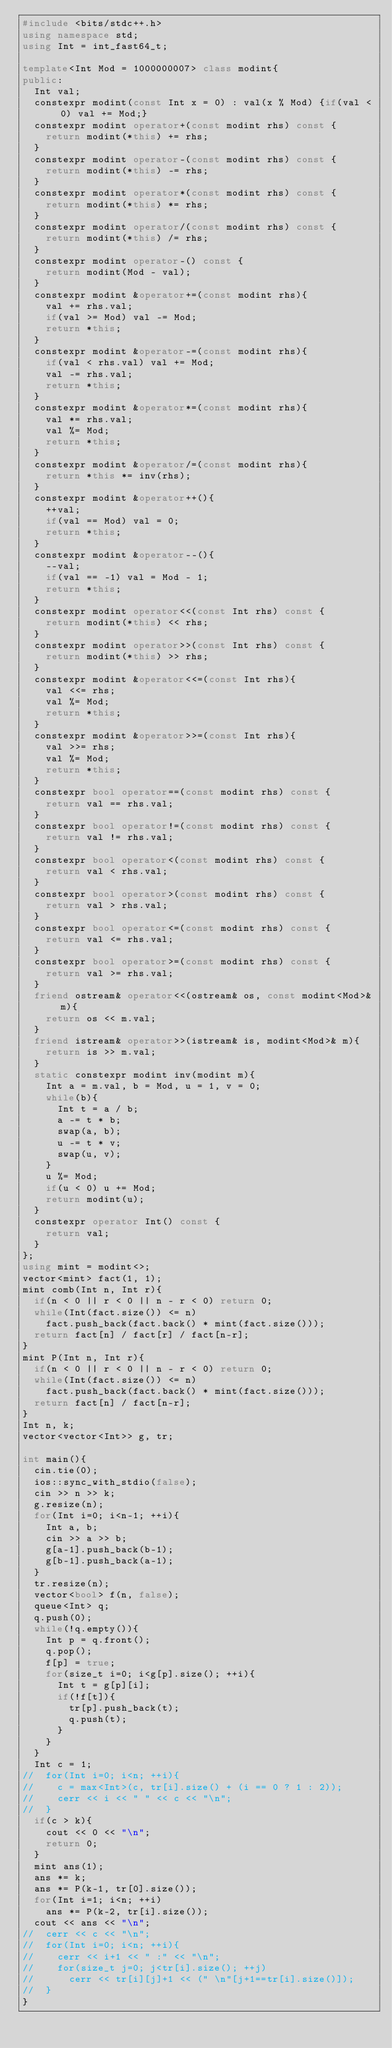Convert code to text. <code><loc_0><loc_0><loc_500><loc_500><_C++_>#include <bits/stdc++.h>
using namespace std;
using Int = int_fast64_t;

template<Int Mod = 1000000007> class modint{
public:
	Int val;
	constexpr modint(const Int x = 0) : val(x % Mod) {if(val < 0) val += Mod;}
	constexpr modint operator+(const modint rhs) const {
		return modint(*this) += rhs;
	}
	constexpr modint operator-(const modint rhs) const {
		return modint(*this) -= rhs;
	}
	constexpr modint operator*(const modint rhs) const {
		return modint(*this) *= rhs;
	}
	constexpr modint operator/(const modint rhs) const {
		return modint(*this) /= rhs;
	}
	constexpr modint operator-() const {
		return modint(Mod - val);
	}
	constexpr modint &operator+=(const modint rhs){
		val += rhs.val;
		if(val >= Mod) val -= Mod;
		return *this;
	}
	constexpr modint &operator-=(const modint rhs){
		if(val < rhs.val) val += Mod;
		val -= rhs.val;
		return *this;
	}
	constexpr modint &operator*=(const modint rhs){
		val *= rhs.val;
		val %= Mod;
		return *this;
	}
	constexpr modint &operator/=(const modint rhs){
		return *this *= inv(rhs);
	}
	constexpr modint &operator++(){
		++val;
		if(val == Mod) val = 0;
		return *this;
	}
	constexpr modint &operator--(){
		--val;
		if(val == -1) val = Mod - 1;
		return *this;
	}
	constexpr modint operator<<(const Int rhs) const {
		return modint(*this) << rhs;
	}
	constexpr modint operator>>(const Int rhs) const {
		return modint(*this) >> rhs;
	}
	constexpr modint &operator<<=(const Int rhs){
		val <<= rhs;
		val %= Mod;
		return *this;
	}
	constexpr modint &operator>>=(const Int rhs){
		val >>= rhs;
		val %= Mod;
		return *this;
	}
	constexpr bool operator==(const modint rhs) const {
		return val == rhs.val;
	}
	constexpr bool operator!=(const modint rhs) const {
		return val != rhs.val;
	}
	constexpr bool operator<(const modint rhs) const {
		return val < rhs.val;
	}
	constexpr bool operator>(const modint rhs) const {
		return val > rhs.val;
	}
	constexpr bool operator<=(const modint rhs) const {
		return val <= rhs.val;
	}
	constexpr bool operator>=(const modint rhs) const {
		return val >= rhs.val;
	}
	friend ostream& operator<<(ostream& os, const modint<Mod>& m){
		return os << m.val;
	}
	friend istream& operator>>(istream& is, modint<Mod>& m){
		return is >> m.val;
	}
	static constexpr modint inv(modint m){
		Int a = m.val, b = Mod, u = 1, v = 0;
		while(b){
			Int t = a / b;
			a -= t * b;
			swap(a, b);
			u -= t * v;
			swap(u, v);
		}
		u %= Mod;
		if(u < 0) u += Mod;
		return modint(u);
	}
	constexpr operator Int() const {
		return val;
	}
};
using mint = modint<>;
vector<mint> fact(1, 1);
mint comb(Int n, Int r){
	if(n < 0 || r < 0 || n - r < 0) return 0;
	while(Int(fact.size()) <= n)
		fact.push_back(fact.back() * mint(fact.size()));
	return fact[n] / fact[r] / fact[n-r];
}
mint P(Int n, Int r){
	if(n < 0 || r < 0 || n - r < 0) return 0;
	while(Int(fact.size()) <= n)
		fact.push_back(fact.back() * mint(fact.size()));
	return fact[n] / fact[n-r];
}
Int n, k;
vector<vector<Int>> g, tr;

int main(){
	cin.tie(0);
	ios::sync_with_stdio(false);
	cin >> n >> k;
	g.resize(n);
	for(Int i=0; i<n-1; ++i){
		Int a, b;
		cin >> a >> b;
		g[a-1].push_back(b-1);
		g[b-1].push_back(a-1);
	}
	tr.resize(n);
	vector<bool> f(n, false);
	queue<Int> q;
	q.push(0);
	while(!q.empty()){
		Int p = q.front();
		q.pop();
		f[p] = true;
		for(size_t i=0; i<g[p].size(); ++i){
			Int t = g[p][i];
			if(!f[t]){
				tr[p].push_back(t);
				q.push(t);
			}
		}
	}
	Int c = 1;
//	for(Int i=0; i<n; ++i){
//		c = max<Int>(c, tr[i].size() + (i == 0 ? 1 : 2));
//		cerr << i << " " << c << "\n";
//	}
	if(c > k){
		cout << 0 << "\n";
		return 0;
	}
	mint ans(1);
	ans *= k;
	ans *= P(k-1, tr[0].size());
	for(Int i=1; i<n; ++i)
		ans *= P(k-2, tr[i].size());
	cout << ans << "\n";
//	cerr << c << "\n";
//	for(Int i=0; i<n; ++i){
//		cerr << i+1 << " :" << "\n";
//		for(size_t j=0; j<tr[i].size(); ++j)
//			cerr << tr[i][j]+1 << (" \n"[j+1==tr[i].size()]);
//	}
}</code> 